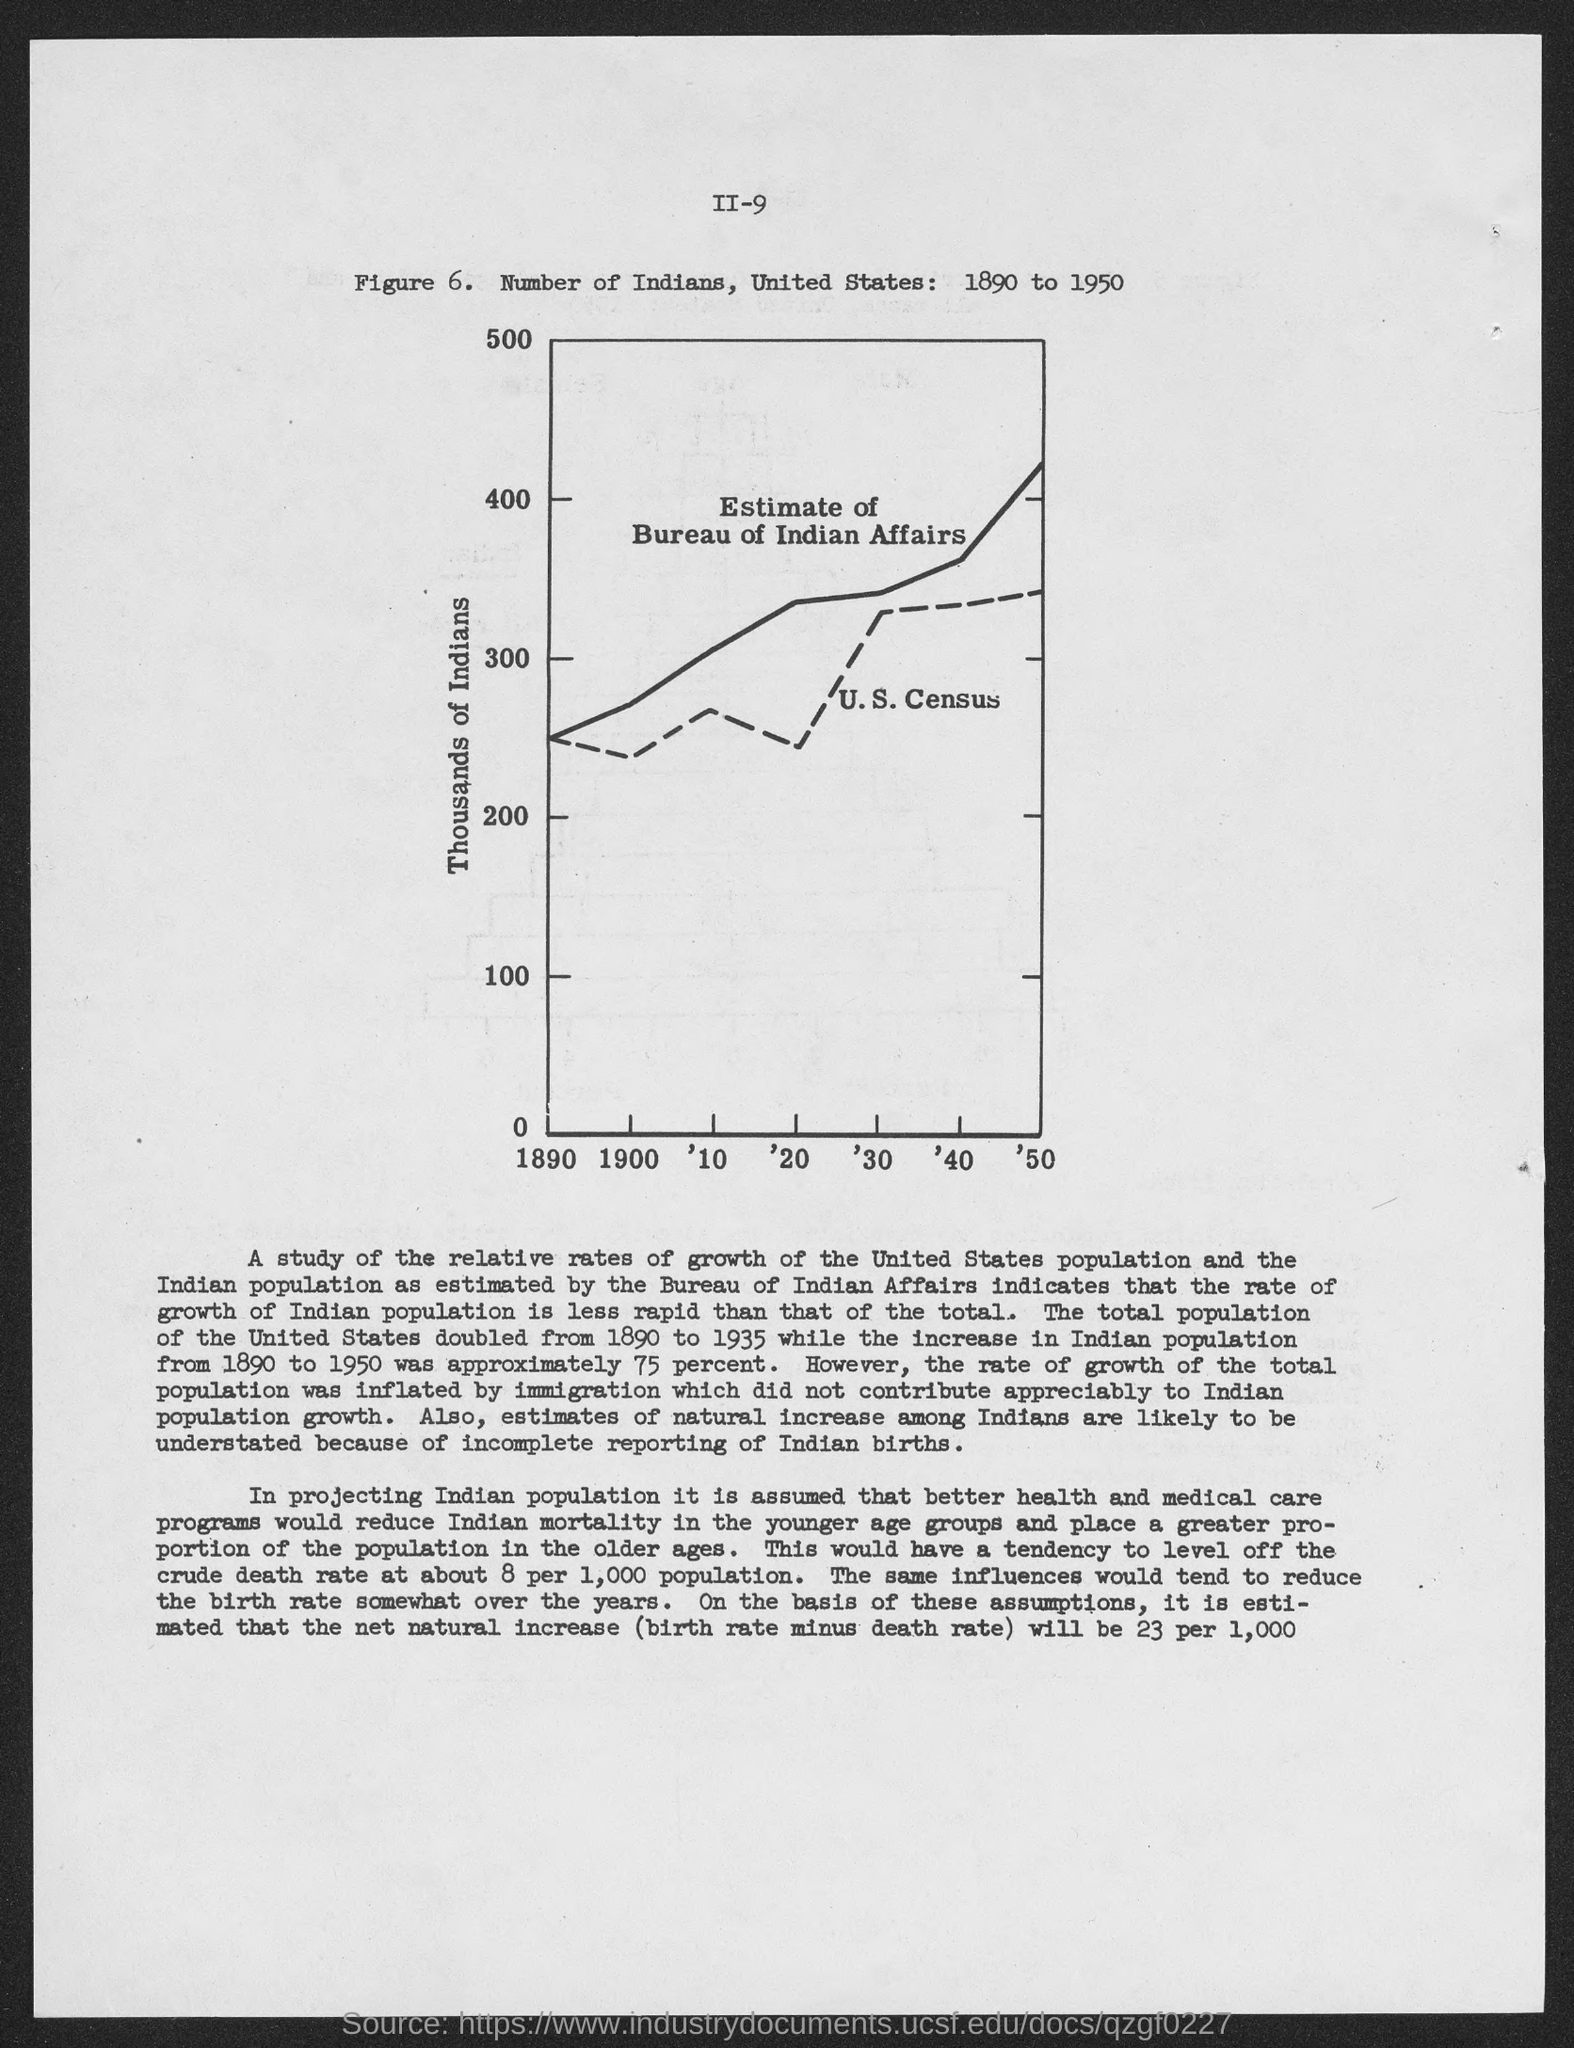Specify some key components in this picture. What is the number? The written on the Y-axis of the figure is "thousands of Indians. 